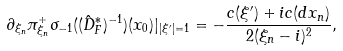<formula> <loc_0><loc_0><loc_500><loc_500>\partial _ { \xi _ { n } } \pi _ { \xi _ { n } } ^ { + } \sigma _ { - 1 } ( ( \hat { D } ^ { * } _ { F } ) ^ { - 1 } ) ( x _ { 0 } ) | _ { | \xi ^ { \prime } | = 1 } = - \frac { c ( \xi ^ { \prime } ) + i c ( d x _ { n } ) } { 2 ( \xi _ { n } - i ) ^ { 2 } } ,</formula> 